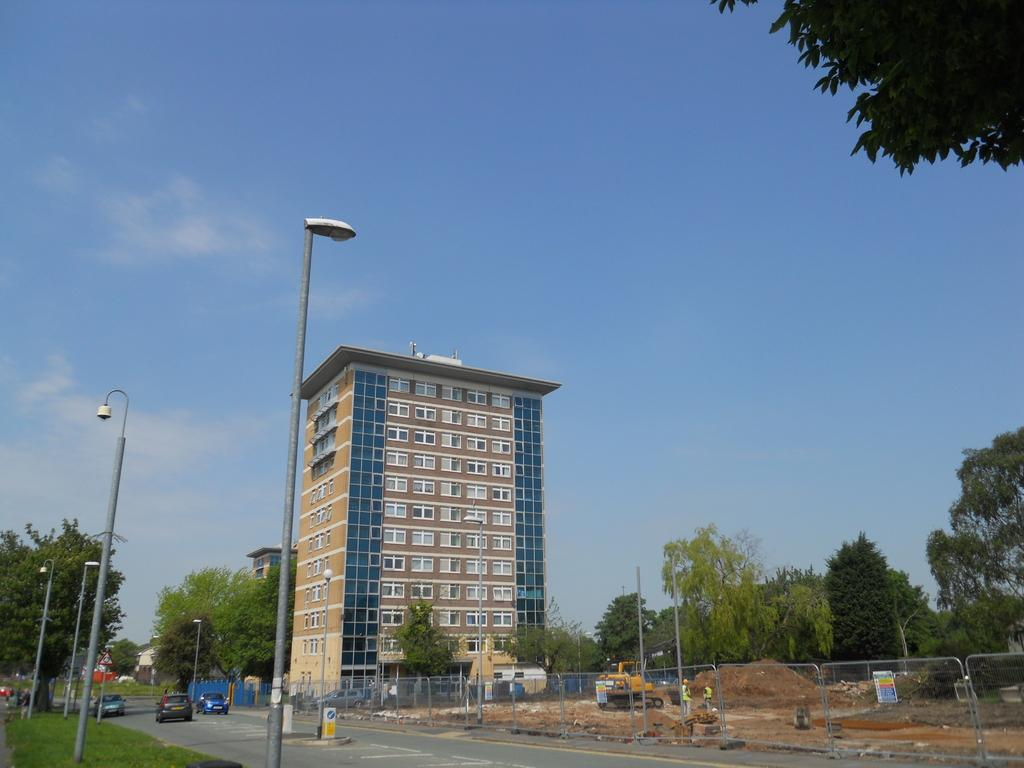What type of structures can be seen in the image? There are light poles, a fence, and a tower building visible in the image. What is happening on the road in the image? Vehicles are moving on the road in the image. What type of natural environment is present in the image? There is grass, sand, and trees visible in the image. What type of machinery can be seen in the image? A bulldozer is visible in the image. What is visible in the background of the image? The sky is visible in the background of the image. Where are the children playing in the image? There are no children present in the image. What type of vegetables are being harvested by the doctor in the image? There is no doctor or tomatoes present in the image. 